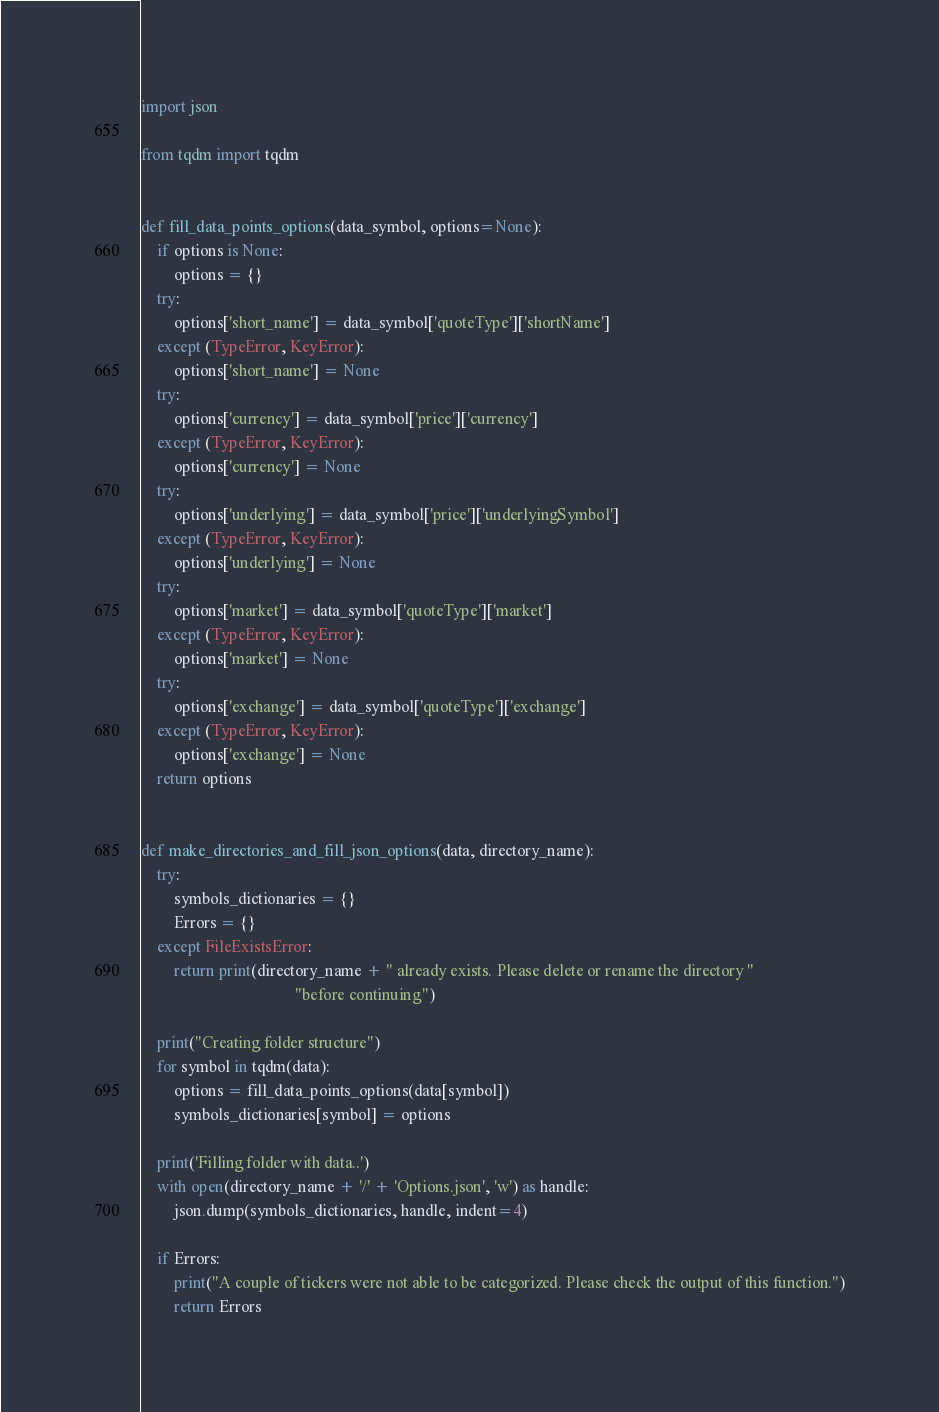<code> <loc_0><loc_0><loc_500><loc_500><_Python_>import json

from tqdm import tqdm


def fill_data_points_options(data_symbol, options=None):
    if options is None:
        options = {}
    try:
        options['short_name'] = data_symbol['quoteType']['shortName']
    except (TypeError, KeyError):
        options['short_name'] = None
    try:
        options['currency'] = data_symbol['price']['currency']
    except (TypeError, KeyError):
        options['currency'] = None
    try:
        options['underlying'] = data_symbol['price']['underlyingSymbol']
    except (TypeError, KeyError):
        options['underlying'] = None
    try:
        options['market'] = data_symbol['quoteType']['market']
    except (TypeError, KeyError):
        options['market'] = None
    try:
        options['exchange'] = data_symbol['quoteType']['exchange']
    except (TypeError, KeyError):
        options['exchange'] = None
    return options


def make_directories_and_fill_json_options(data, directory_name):
    try:
        symbols_dictionaries = {}
        Errors = {}
    except FileExistsError:
        return print(directory_name + " already exists. Please delete or rename the directory "
                                      "before continuing")

    print("Creating folder structure")
    for symbol in tqdm(data):
        options = fill_data_points_options(data[symbol])
        symbols_dictionaries[symbol] = options

    print('Filling folder with data..')
    with open(directory_name + '/' + 'Options.json', 'w') as handle:
        json.dump(symbols_dictionaries, handle, indent=4)

    if Errors:
        print("A couple of tickers were not able to be categorized. Please check the output of this function.")
        return Errors
</code> 